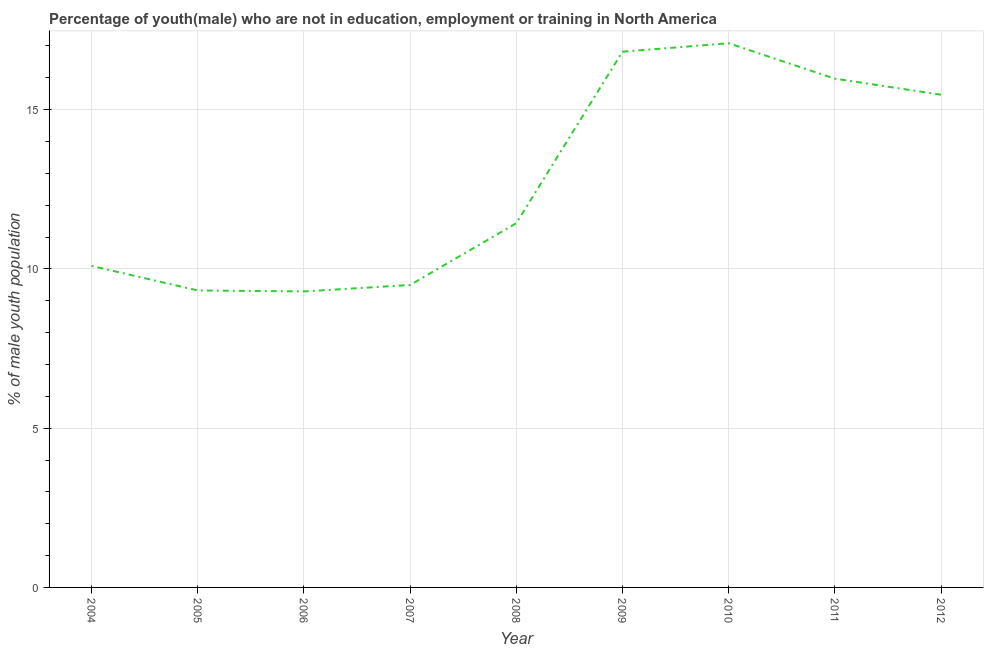What is the unemployed male youth population in 2010?
Offer a terse response. 17.08. Across all years, what is the maximum unemployed male youth population?
Give a very brief answer. 17.08. Across all years, what is the minimum unemployed male youth population?
Give a very brief answer. 9.29. What is the sum of the unemployed male youth population?
Provide a short and direct response. 114.98. What is the difference between the unemployed male youth population in 2007 and 2012?
Give a very brief answer. -5.97. What is the average unemployed male youth population per year?
Offer a very short reply. 12.78. What is the median unemployed male youth population?
Provide a succinct answer. 11.43. In how many years, is the unemployed male youth population greater than 14 %?
Give a very brief answer. 4. What is the ratio of the unemployed male youth population in 2009 to that in 2011?
Your answer should be very brief. 1.05. Is the difference between the unemployed male youth population in 2005 and 2007 greater than the difference between any two years?
Keep it short and to the point. No. What is the difference between the highest and the second highest unemployed male youth population?
Your answer should be very brief. 0.27. What is the difference between the highest and the lowest unemployed male youth population?
Keep it short and to the point. 7.79. In how many years, is the unemployed male youth population greater than the average unemployed male youth population taken over all years?
Give a very brief answer. 4. Does the unemployed male youth population monotonically increase over the years?
Provide a succinct answer. No. How many lines are there?
Keep it short and to the point. 1. Are the values on the major ticks of Y-axis written in scientific E-notation?
Your answer should be very brief. No. Does the graph contain any zero values?
Offer a very short reply. No. What is the title of the graph?
Your answer should be very brief. Percentage of youth(male) who are not in education, employment or training in North America. What is the label or title of the X-axis?
Make the answer very short. Year. What is the label or title of the Y-axis?
Your answer should be very brief. % of male youth population. What is the % of male youth population of 2004?
Ensure brevity in your answer.  10.09. What is the % of male youth population in 2005?
Your response must be concise. 9.32. What is the % of male youth population of 2006?
Your answer should be very brief. 9.29. What is the % of male youth population in 2007?
Your answer should be very brief. 9.5. What is the % of male youth population in 2008?
Provide a succinct answer. 11.43. What is the % of male youth population of 2009?
Your answer should be compact. 16.82. What is the % of male youth population in 2010?
Provide a short and direct response. 17.08. What is the % of male youth population in 2011?
Keep it short and to the point. 15.97. What is the % of male youth population in 2012?
Ensure brevity in your answer.  15.47. What is the difference between the % of male youth population in 2004 and 2005?
Your answer should be very brief. 0.77. What is the difference between the % of male youth population in 2004 and 2006?
Offer a very short reply. 0.8. What is the difference between the % of male youth population in 2004 and 2007?
Ensure brevity in your answer.  0.6. What is the difference between the % of male youth population in 2004 and 2008?
Provide a succinct answer. -1.34. What is the difference between the % of male youth population in 2004 and 2009?
Offer a very short reply. -6.73. What is the difference between the % of male youth population in 2004 and 2010?
Your answer should be very brief. -6.99. What is the difference between the % of male youth population in 2004 and 2011?
Provide a succinct answer. -5.88. What is the difference between the % of male youth population in 2004 and 2012?
Provide a short and direct response. -5.38. What is the difference between the % of male youth population in 2005 and 2006?
Your response must be concise. 0.03. What is the difference between the % of male youth population in 2005 and 2007?
Provide a succinct answer. -0.17. What is the difference between the % of male youth population in 2005 and 2008?
Offer a terse response. -2.11. What is the difference between the % of male youth population in 2005 and 2009?
Your answer should be compact. -7.5. What is the difference between the % of male youth population in 2005 and 2010?
Keep it short and to the point. -7.76. What is the difference between the % of male youth population in 2005 and 2011?
Offer a very short reply. -6.65. What is the difference between the % of male youth population in 2005 and 2012?
Provide a succinct answer. -6.15. What is the difference between the % of male youth population in 2006 and 2007?
Keep it short and to the point. -0.2. What is the difference between the % of male youth population in 2006 and 2008?
Your response must be concise. -2.14. What is the difference between the % of male youth population in 2006 and 2009?
Ensure brevity in your answer.  -7.53. What is the difference between the % of male youth population in 2006 and 2010?
Your response must be concise. -7.79. What is the difference between the % of male youth population in 2006 and 2011?
Your response must be concise. -6.68. What is the difference between the % of male youth population in 2006 and 2012?
Offer a very short reply. -6.18. What is the difference between the % of male youth population in 2007 and 2008?
Your answer should be very brief. -1.94. What is the difference between the % of male youth population in 2007 and 2009?
Provide a short and direct response. -7.32. What is the difference between the % of male youth population in 2007 and 2010?
Ensure brevity in your answer.  -7.59. What is the difference between the % of male youth population in 2007 and 2011?
Give a very brief answer. -6.48. What is the difference between the % of male youth population in 2007 and 2012?
Offer a very short reply. -5.97. What is the difference between the % of male youth population in 2008 and 2009?
Your answer should be very brief. -5.38. What is the difference between the % of male youth population in 2008 and 2010?
Offer a terse response. -5.65. What is the difference between the % of male youth population in 2008 and 2011?
Provide a succinct answer. -4.54. What is the difference between the % of male youth population in 2008 and 2012?
Keep it short and to the point. -4.03. What is the difference between the % of male youth population in 2009 and 2010?
Your response must be concise. -0.27. What is the difference between the % of male youth population in 2009 and 2011?
Your answer should be very brief. 0.85. What is the difference between the % of male youth population in 2009 and 2012?
Offer a terse response. 1.35. What is the difference between the % of male youth population in 2010 and 2011?
Your response must be concise. 1.11. What is the difference between the % of male youth population in 2010 and 2012?
Provide a succinct answer. 1.62. What is the difference between the % of male youth population in 2011 and 2012?
Make the answer very short. 0.5. What is the ratio of the % of male youth population in 2004 to that in 2005?
Provide a short and direct response. 1.08. What is the ratio of the % of male youth population in 2004 to that in 2006?
Keep it short and to the point. 1.09. What is the ratio of the % of male youth population in 2004 to that in 2007?
Offer a very short reply. 1.06. What is the ratio of the % of male youth population in 2004 to that in 2008?
Your response must be concise. 0.88. What is the ratio of the % of male youth population in 2004 to that in 2010?
Provide a short and direct response. 0.59. What is the ratio of the % of male youth population in 2004 to that in 2011?
Your answer should be very brief. 0.63. What is the ratio of the % of male youth population in 2004 to that in 2012?
Offer a very short reply. 0.65. What is the ratio of the % of male youth population in 2005 to that in 2006?
Keep it short and to the point. 1. What is the ratio of the % of male youth population in 2005 to that in 2007?
Keep it short and to the point. 0.98. What is the ratio of the % of male youth population in 2005 to that in 2008?
Provide a succinct answer. 0.81. What is the ratio of the % of male youth population in 2005 to that in 2009?
Keep it short and to the point. 0.55. What is the ratio of the % of male youth population in 2005 to that in 2010?
Give a very brief answer. 0.55. What is the ratio of the % of male youth population in 2005 to that in 2011?
Ensure brevity in your answer.  0.58. What is the ratio of the % of male youth population in 2005 to that in 2012?
Keep it short and to the point. 0.6. What is the ratio of the % of male youth population in 2006 to that in 2007?
Your response must be concise. 0.98. What is the ratio of the % of male youth population in 2006 to that in 2008?
Provide a short and direct response. 0.81. What is the ratio of the % of male youth population in 2006 to that in 2009?
Your answer should be compact. 0.55. What is the ratio of the % of male youth population in 2006 to that in 2010?
Offer a terse response. 0.54. What is the ratio of the % of male youth population in 2006 to that in 2011?
Your response must be concise. 0.58. What is the ratio of the % of male youth population in 2006 to that in 2012?
Your answer should be compact. 0.6. What is the ratio of the % of male youth population in 2007 to that in 2008?
Provide a succinct answer. 0.83. What is the ratio of the % of male youth population in 2007 to that in 2009?
Give a very brief answer. 0.56. What is the ratio of the % of male youth population in 2007 to that in 2010?
Offer a very short reply. 0.56. What is the ratio of the % of male youth population in 2007 to that in 2011?
Your answer should be compact. 0.59. What is the ratio of the % of male youth population in 2007 to that in 2012?
Provide a succinct answer. 0.61. What is the ratio of the % of male youth population in 2008 to that in 2009?
Offer a terse response. 0.68. What is the ratio of the % of male youth population in 2008 to that in 2010?
Your answer should be very brief. 0.67. What is the ratio of the % of male youth population in 2008 to that in 2011?
Provide a short and direct response. 0.72. What is the ratio of the % of male youth population in 2008 to that in 2012?
Offer a very short reply. 0.74. What is the ratio of the % of male youth population in 2009 to that in 2010?
Give a very brief answer. 0.98. What is the ratio of the % of male youth population in 2009 to that in 2011?
Your response must be concise. 1.05. What is the ratio of the % of male youth population in 2009 to that in 2012?
Ensure brevity in your answer.  1.09. What is the ratio of the % of male youth population in 2010 to that in 2011?
Your response must be concise. 1.07. What is the ratio of the % of male youth population in 2010 to that in 2012?
Your response must be concise. 1.1. What is the ratio of the % of male youth population in 2011 to that in 2012?
Give a very brief answer. 1.03. 